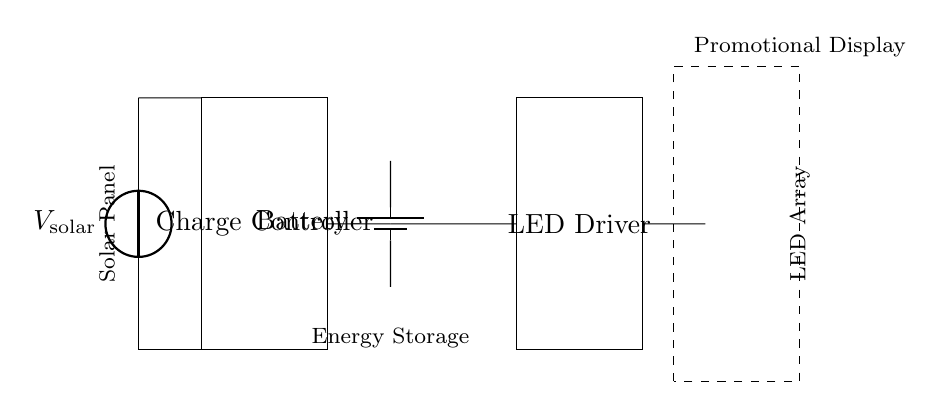What is the main energy source for this circuit? The main energy source for this circuit is the solar panel, which harnesses solar energy and converts it into electrical energy to charge the battery.
Answer: solar panel What component is responsible for regulating charging? The charge controller is responsible for regulating the charging process of the battery, ensuring that it does not overcharge and maintains optimal charging conditions.
Answer: charge controller How many LEDs are in the array? The LED array contains three LEDs as shown in the diagram, which are connected in parallel and used for illumination in the promotional display.
Answer: three What type of energy storage is used in this circuit? The energy storage type used in this circuit is a battery, which stores the energy generated by the solar panel for later use when the display needs illumination.
Answer: battery What does the dashed rectangle represent? The dashed rectangle represents the promotional display, which serves as the intended application for the power supplied by the solar-powered charging circuit, indicating where the LED array will be installed.
Answer: promotional display How does the energy flow from the solar panel to the LED array? The energy flows from the solar panel to the charge controller, then charges the battery. The LED driver receives the energy stored in the battery and supplies it to the LED array for lighting.
Answer: from solar panel to charge controller to battery to LED driver to LED array 